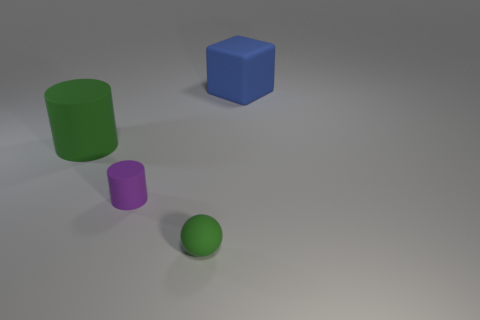There is a green object left of the purple matte object; does it have the same shape as the small green object?
Give a very brief answer. No. Are there any other green balls that have the same size as the rubber sphere?
Offer a very short reply. No. Does the large green rubber thing have the same shape as the rubber thing in front of the tiny purple object?
Offer a very short reply. No. There is a matte object that is the same color as the tiny ball; what is its shape?
Keep it short and to the point. Cylinder. Are there fewer cubes that are to the left of the small purple rubber object than small brown cylinders?
Your answer should be very brief. No. Do the blue rubber object and the small green object have the same shape?
Your answer should be compact. No. What is the size of the green sphere that is made of the same material as the large blue block?
Make the answer very short. Small. Is the number of rubber blocks less than the number of tiny shiny cylinders?
Give a very brief answer. No. What number of large objects are green rubber spheres or blue cubes?
Give a very brief answer. 1. How many objects are on the right side of the big green matte cylinder and behind the purple thing?
Your answer should be very brief. 1. 